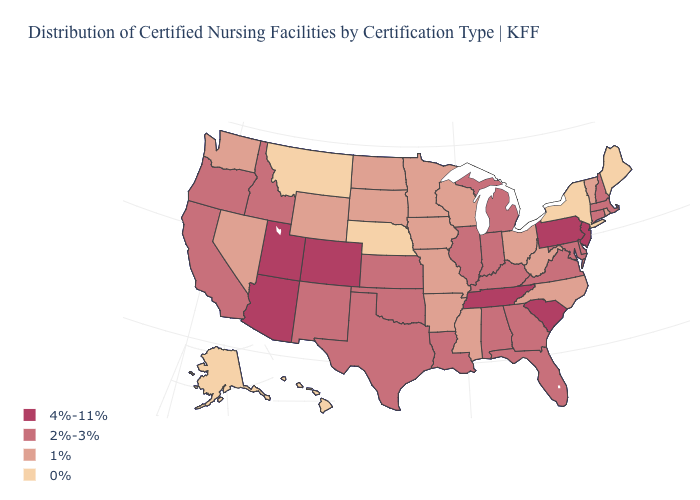Which states have the lowest value in the USA?
Be succinct. Alaska, Hawaii, Maine, Montana, Nebraska, New York. Does Arizona have the highest value in the USA?
Short answer required. Yes. Among the states that border Rhode Island , which have the lowest value?
Keep it brief. Connecticut, Massachusetts. What is the highest value in states that border Maine?
Write a very short answer. 2%-3%. What is the value of South Dakota?
Quick response, please. 1%. What is the lowest value in the USA?
Short answer required. 0%. Does the map have missing data?
Concise answer only. No. What is the highest value in the South ?
Concise answer only. 4%-11%. Does Alabama have a higher value than Rhode Island?
Be succinct. Yes. What is the value of Connecticut?
Be succinct. 2%-3%. What is the lowest value in the South?
Quick response, please. 1%. Which states have the highest value in the USA?
Keep it brief. Arizona, Colorado, New Jersey, Pennsylvania, South Carolina, Tennessee, Utah. Which states have the highest value in the USA?
Answer briefly. Arizona, Colorado, New Jersey, Pennsylvania, South Carolina, Tennessee, Utah. How many symbols are there in the legend?
Give a very brief answer. 4. What is the lowest value in states that border Wisconsin?
Short answer required. 1%. 